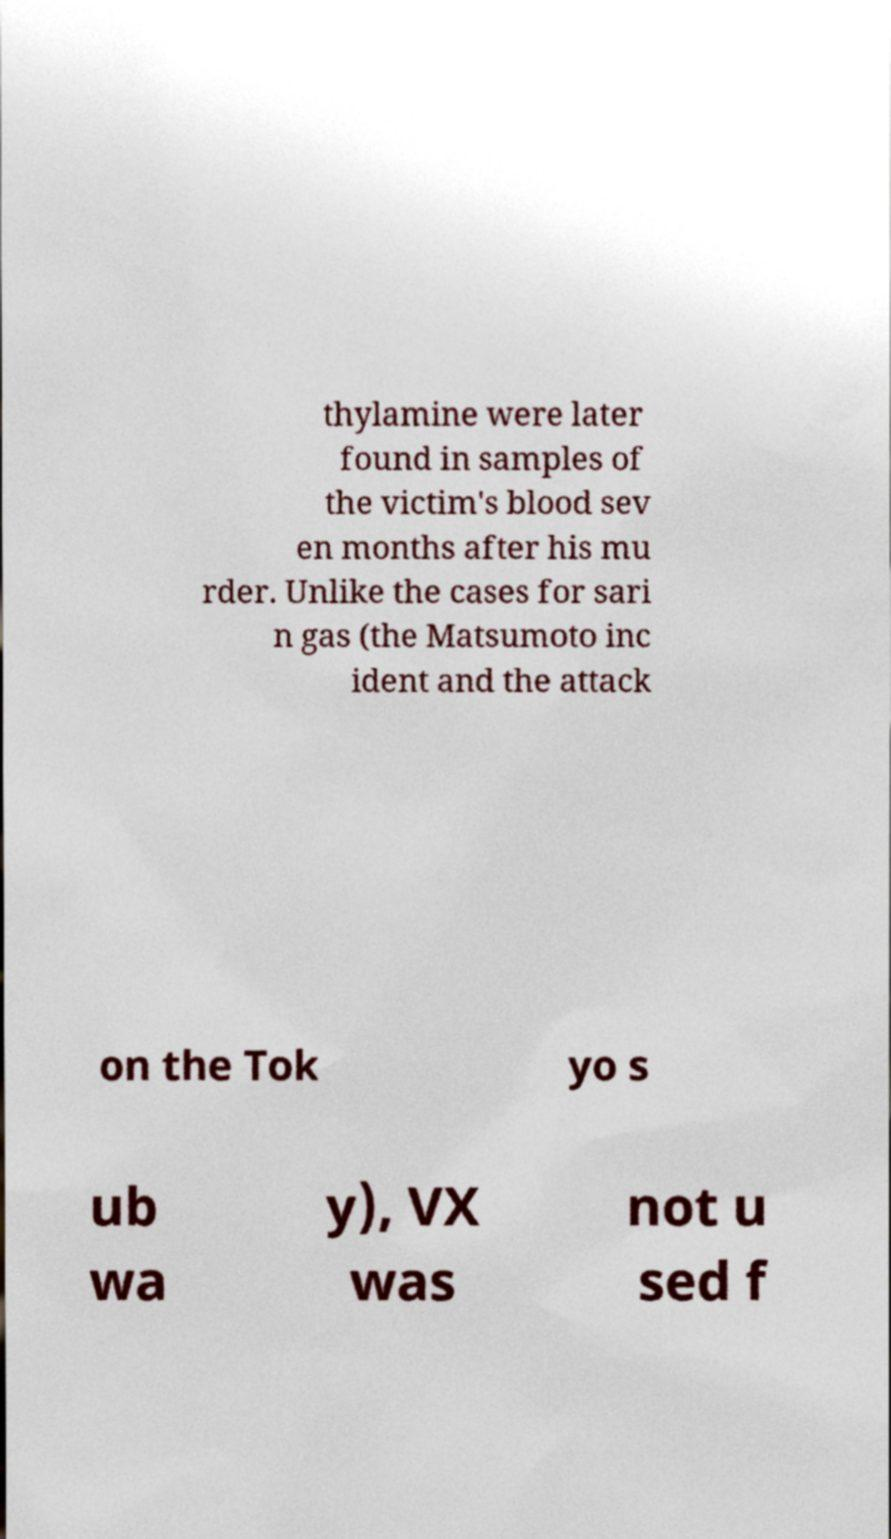Could you assist in decoding the text presented in this image and type it out clearly? thylamine were later found in samples of the victim's blood sev en months after his mu rder. Unlike the cases for sari n gas (the Matsumoto inc ident and the attack on the Tok yo s ub wa y), VX was not u sed f 